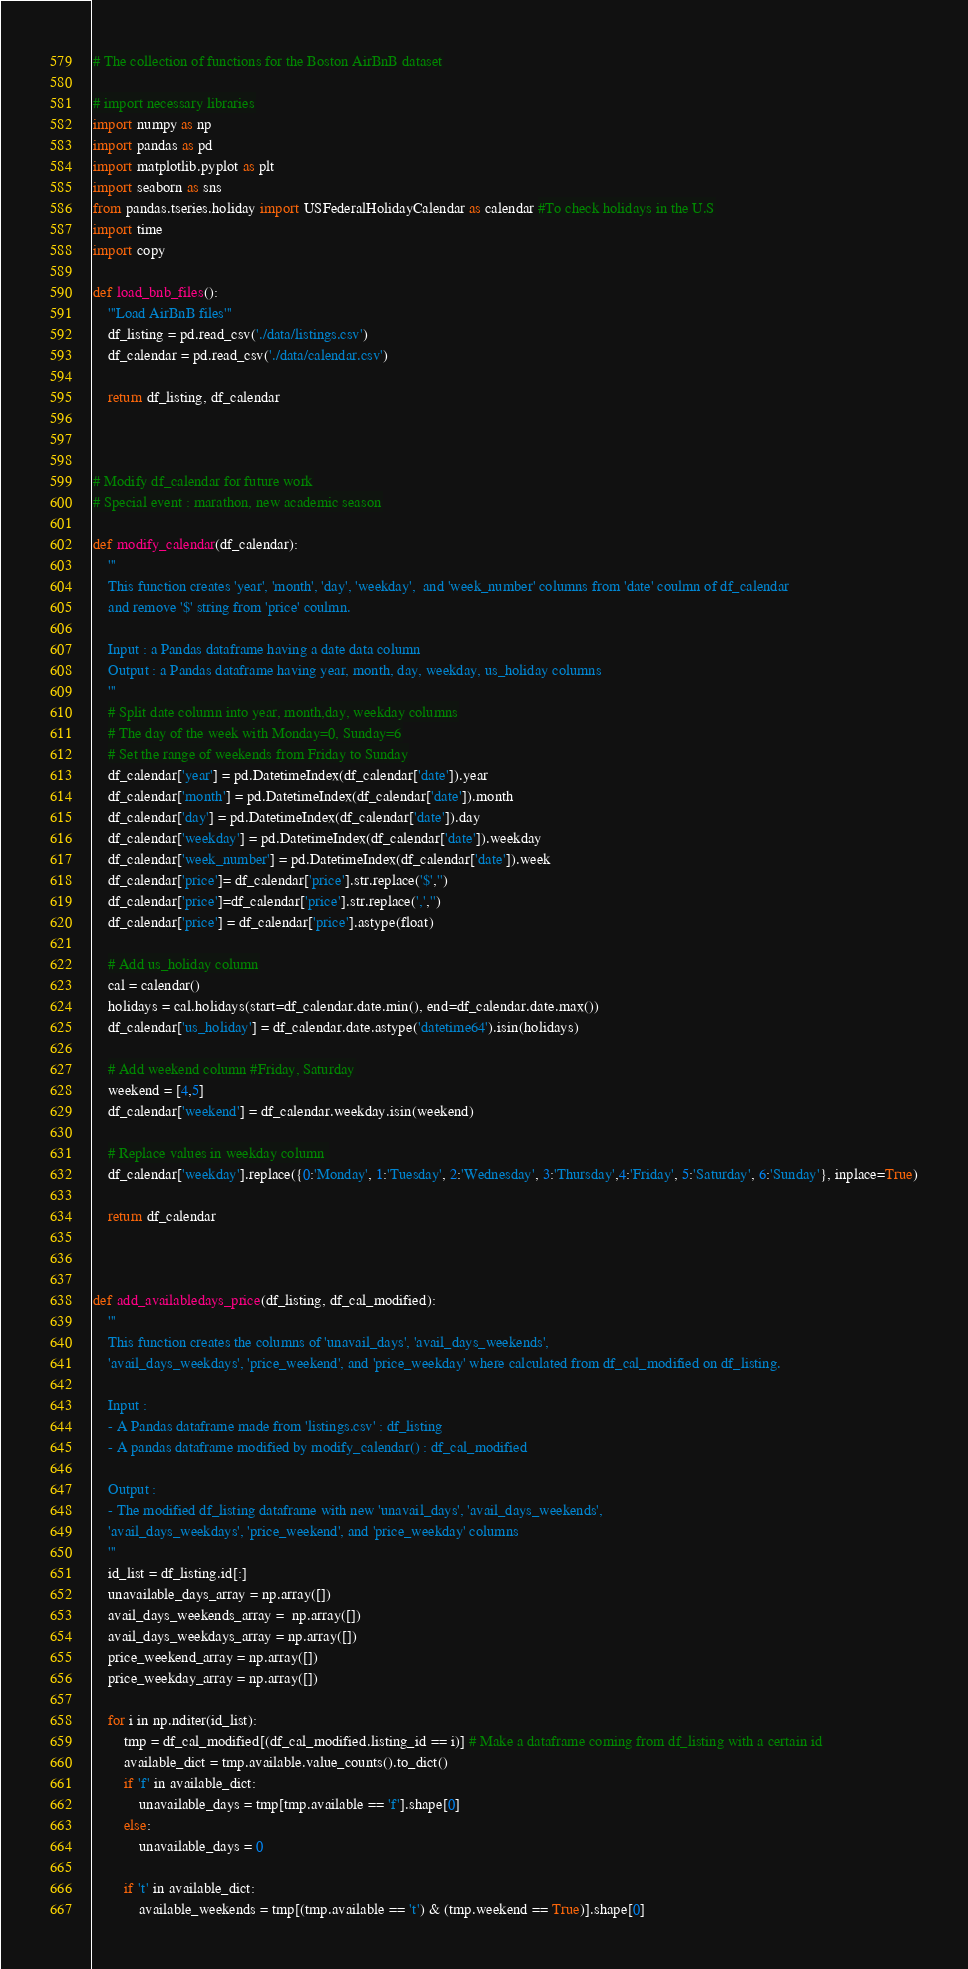Convert code to text. <code><loc_0><loc_0><loc_500><loc_500><_Python_># The collection of functions for the Boston AirBnB dataset

# import necessary libraries
import numpy as np
import pandas as pd
import matplotlib.pyplot as plt
import seaborn as sns
from pandas.tseries.holiday import USFederalHolidayCalendar as calendar #To check holidays in the U.S
import time
import copy

def load_bnb_files():
    '''Load AirBnB files'''
    df_listing = pd.read_csv('./data/listings.csv')
    df_calendar = pd.read_csv('./data/calendar.csv')

    return df_listing, df_calendar



# Modify df_calendar for future work
# Special event : marathon, new academic season

def modify_calendar(df_calendar):
    '''
    This function creates 'year', 'month', 'day', 'weekday',  and 'week_number' columns from 'date' coulmn of df_calendar 
    and remove '$' string from 'price' coulmn.
    
    Input : a Pandas dataframe having a date data column
    Output : a Pandas dataframe having year, month, day, weekday, us_holiday columns
    '''
    # Split date column into year, month,day, weekday columns
    # The day of the week with Monday=0, Sunday=6
    # Set the range of weekends from Friday to Sunday
    df_calendar['year'] = pd.DatetimeIndex(df_calendar['date']).year
    df_calendar['month'] = pd.DatetimeIndex(df_calendar['date']).month
    df_calendar['day'] = pd.DatetimeIndex(df_calendar['date']).day
    df_calendar['weekday'] = pd.DatetimeIndex(df_calendar['date']).weekday
    df_calendar['week_number'] = pd.DatetimeIndex(df_calendar['date']).week
    df_calendar['price']= df_calendar['price'].str.replace('$','')
    df_calendar['price']=df_calendar['price'].str.replace(',','')
    df_calendar['price'] = df_calendar['price'].astype(float)
    
    # Add us_holiday column
    cal = calendar()
    holidays = cal.holidays(start=df_calendar.date.min(), end=df_calendar.date.max())
    df_calendar['us_holiday'] = df_calendar.date.astype('datetime64').isin(holidays)
    
    # Add weekend column #Friday, Saturday
    weekend = [4,5]
    df_calendar['weekend'] = df_calendar.weekday.isin(weekend)
    
    # Replace values in weekday column 
    df_calendar['weekday'].replace({0:'Monday', 1:'Tuesday', 2:'Wednesday', 3:'Thursday',4:'Friday', 5:'Saturday', 6:'Sunday'}, inplace=True)
    
    return df_calendar



def add_availabledays_price(df_listing, df_cal_modified):
    '''
    This function creates the columns of 'unavail_days', 'avail_days_weekends', 
    'avail_days_weekdays', 'price_weekend', and 'price_weekday' where calculated from df_cal_modified on df_listing.
    
    Input : 
    - A Pandas dataframe made from 'listings.csv' : df_listing
    - A pandas dataframe modified by modify_calendar() : df_cal_modified
    
    Output :
    - The modified df_listing dataframe with new 'unavail_days', 'avail_days_weekends',
    'avail_days_weekdays', 'price_weekend', and 'price_weekday' columns 
    '''
    id_list = df_listing.id[:]
    unavailable_days_array = np.array([])
    avail_days_weekends_array =  np.array([])
    avail_days_weekdays_array = np.array([])
    price_weekend_array = np.array([])
    price_weekday_array = np.array([])

    for i in np.nditer(id_list):
        tmp = df_cal_modified[(df_cal_modified.listing_id == i)] # Make a dataframe coming from df_listing with a certain id
        available_dict = tmp.available.value_counts().to_dict()
        if 'f' in available_dict:
            unavailable_days = tmp[tmp.available == 'f'].shape[0]
        else:
            unavailable_days = 0

        if 't' in available_dict:
            available_weekends = tmp[(tmp.available == 't') & (tmp.weekend == True)].shape[0]</code> 